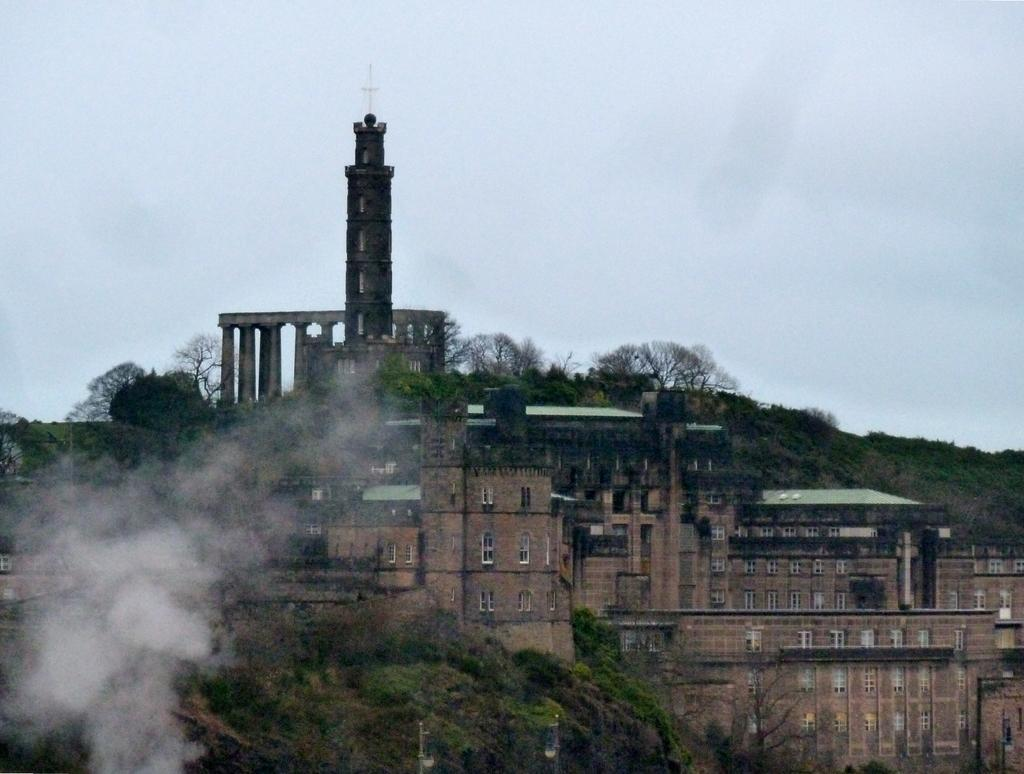What is located in the middle of the image? There are buildings and trees in the middle of the image. Can you describe the smoke in the image? The smoke is on the left side of the image. What type of vest is visible on the ground in the image? There is no vest or any other clothing item present in the image. 